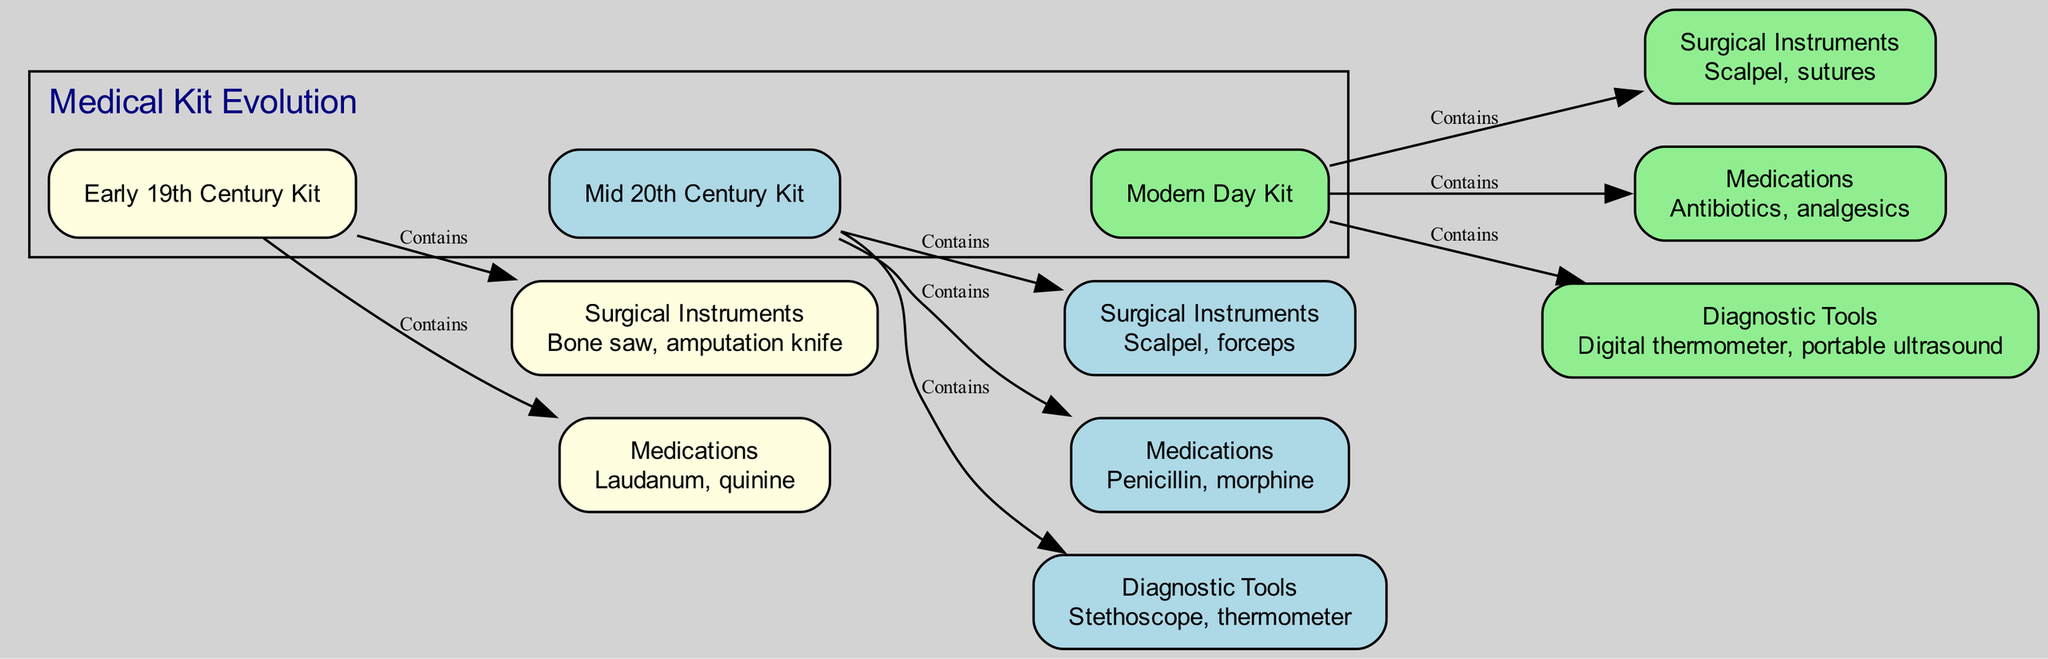What does the early 19th century kit contain? The early 19th century kit contains surgical instruments like a bone saw and an amputation knife, and medications such as laudanum and quinine, as indicated by the edges connecting it to those nodes.
Answer: Surgical instruments, medications What type of surgical instruments are present in the mid 20th century kit? The mid 20th century kit contains surgical instruments specifically listed as a scalpel and forceps, as shown in the diagram under the corresponding nodes.
Answer: Scalpel, forceps How many diagnostic tools are shown in the modern day kit? The modern day kit includes one diagnostic tool, which is the digital thermometer and portable ultrasound, but they are grouped under one node indicating the category rather than counting them separately.
Answer: 1 Which medications are found in the modern day kit? The modern day kit lists antibiotics and analgesics as the medications available, based on the labeling in the diagram for that specific node.
Answer: Antibiotics, analgesics What are the two categories of items in the early 19th century kit? The early 19th century kit contains two categories of items: surgical instruments and medications, as indicated by the nodes connected to it through the edges labeled "Contains."
Answer: Surgical instruments, medications What diagnostic tools are available in the mid 20th century kit? The mid 20th century kit features diagnostic tools such as a stethoscope and thermometer, specified in the node dedicated to diagnostic tools.
Answer: Stethoscope, thermometer Which kit has the most advanced surgical instruments? The modern day kit has the most advanced surgical instruments, which include scalpel and sutures, as shown in the corresponding node that indicates modern equipment.
Answer: Modern day kit How many total kits are shown in the diagram? The diagram depicts three distinct kits: early 19th century kit, mid 20th century kit, and modern day kit, clearly outlined in separate nodes.
Answer: 3 What is the label for the mid 20th century kit? The mid 20th century kit is labeled as "Mid 20th Century Kit," which can be seen directly in the diagram by looking at the node representing that era's kit.
Answer: Mid 20th Century Kit 